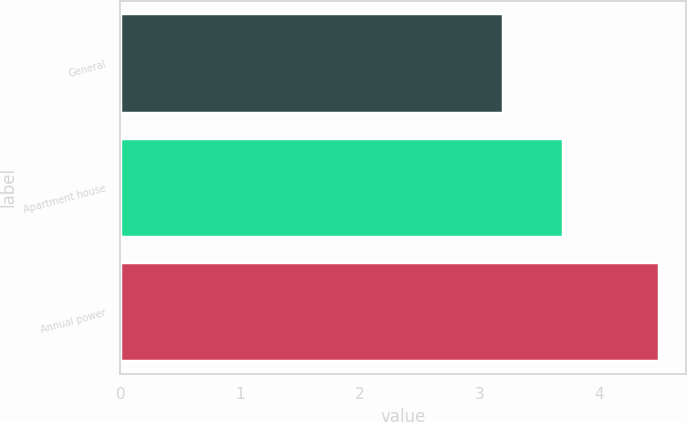<chart> <loc_0><loc_0><loc_500><loc_500><bar_chart><fcel>General<fcel>Apartment house<fcel>Annual power<nl><fcel>3.2<fcel>3.7<fcel>4.5<nl></chart> 